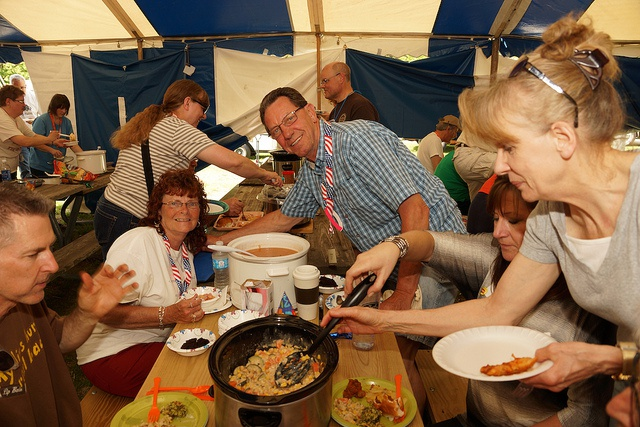Describe the objects in this image and their specific colors. I can see people in tan, brown, and black tones, people in tan, gray, darkgray, brown, and black tones, people in tan, maroon, black, and brown tones, people in tan, maroon, black, and brown tones, and dining table in tan, olive, maroon, and black tones in this image. 